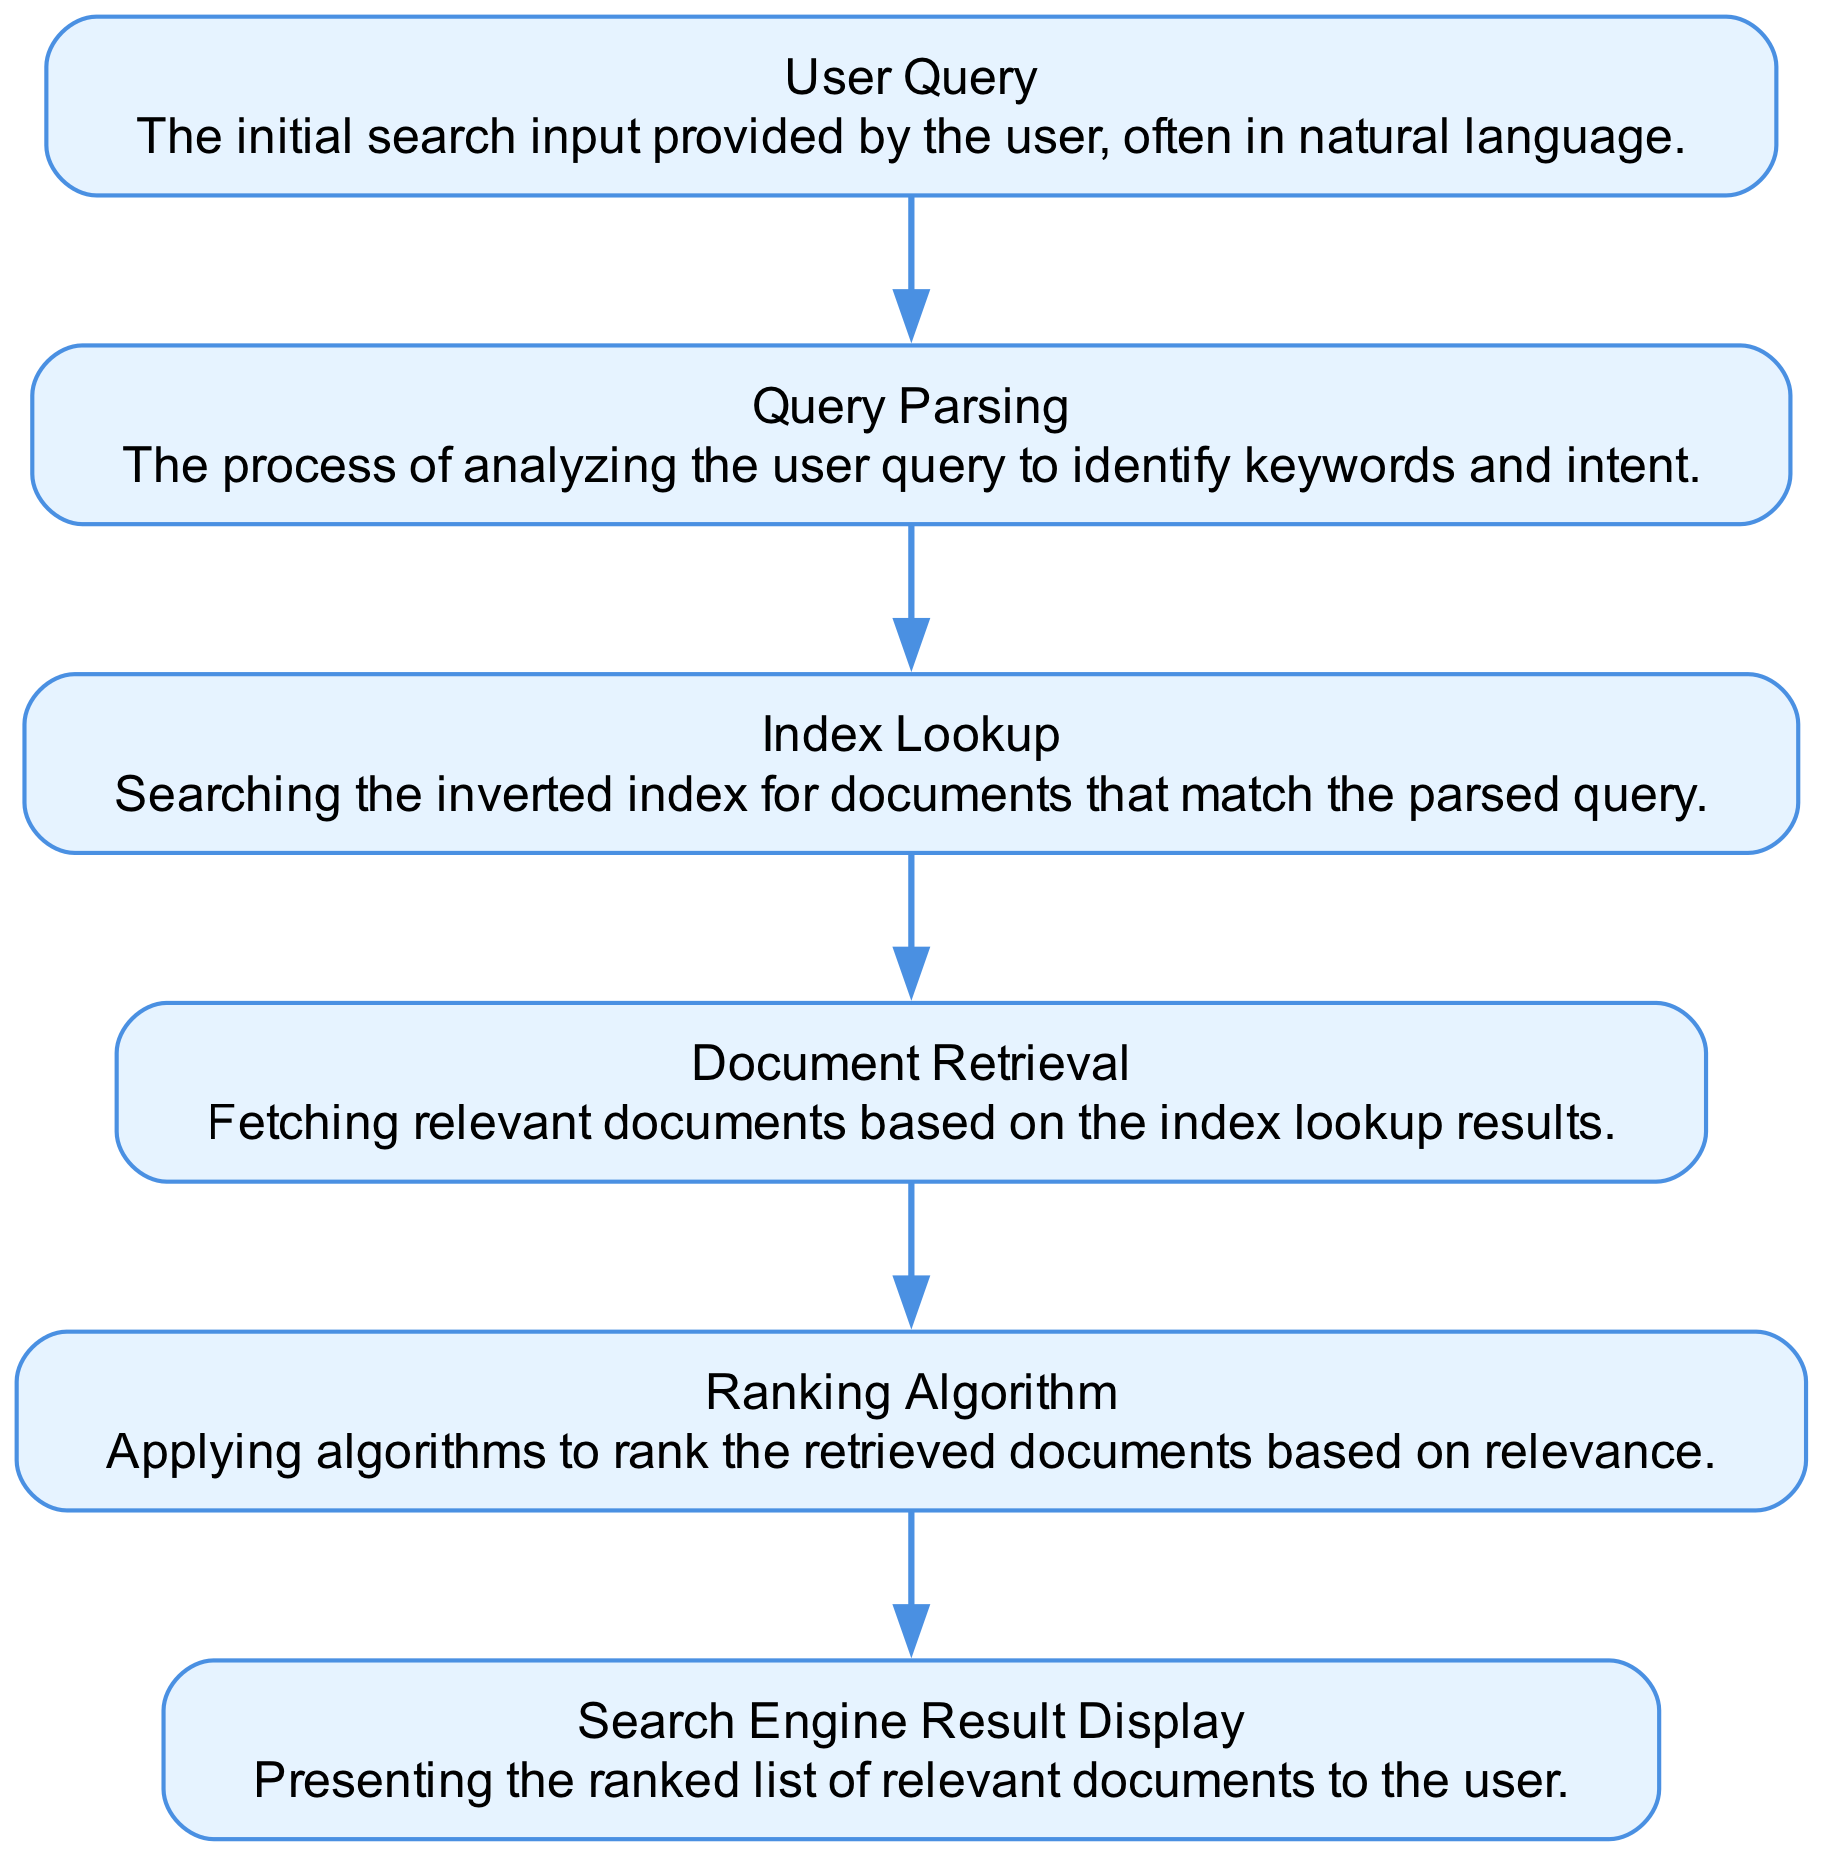What is the first step in the information retrieval process? The first step in the diagram is labeled "User Query," where the user inputs their search criteria.
Answer: User Query How many nodes are present in the flow chart? The flow chart includes six nodes: User Query, Query Parsing, Index Lookup, Document Retrieval, Ranking Algorithm, and Search Engine Result Display.
Answer: Six What is the last step before displaying search results? The last step before displaying results is "Ranking Algorithm," which ranks the documents based on relevance before presenting them.
Answer: Ranking Algorithm Which node follows Query Parsing? The node that follows "Query Parsing" is "Index Lookup," indicating that after parsing, the system looks up the index for relevant documents.
Answer: Index Lookup What action is taken after Document Retrieval? After "Document Retrieval," the next action taken is to apply the "Ranking Algorithm," which sorts the documents by relevance.
Answer: Ranking Algorithm Which two nodes are directly connected to the result display? The "Search Engine Result Display" node is directly connected to the "Ranking Algorithm," as only the ranked documents are presented as results to the user.
Answer: Ranking Algorithm What does the "Index Lookup" node perform? The "Index Lookup" node performs a search in the inverted index for documents that match the parsed user query, which is essential to retrieve relevant content.
Answer: Searching the inverted index What is the primary purpose of the Query Parsing step? The primary purpose of "Query Parsing" is to analyze the user's query to identify keywords and the user's intent, which is critical for effective search results.
Answer: Analyzing the user query How is the relationship between Document Retrieval and Ranking Algorithm characterized? The relationship is characterized as a sequential process where after relevant documents are fetched in "Document Retrieval," they are ranked by the "Ranking Algorithm."
Answer: Sequential process 